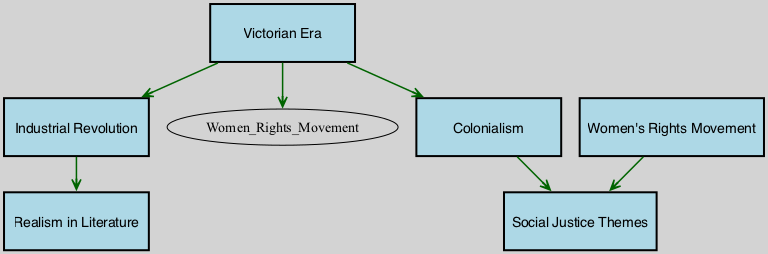What are the total number of nodes in the diagram? There are 6 distinct nodes in the diagram: Victorian Era, Women's Rights Movement, Colonialism, Industrial Revolution, Realism in Literature, and Social Justice Themes.
Answer: 6 Which node is influenced by both Victorian Era and Industrial Revolution? The diagram shows that Realism in Literature is influenced by the Industrial Revolution, and the Victorian Era has direct edges to Women's Rights Movement and Colonialism. Therefore, Realism in Literature is solely influenced by the Industrial Revolution.
Answer: Realism in Literature How many edges lead from the Victorian Era? The Victorian Era has three edges leading to other nodes: Women's Rights Movement, Colonialism, and Industrial Revolution. Counting these edges gives a total of 3.
Answer: 3 What influences the Social Justice Themes node? The Social Justice Themes node is influenced by two edges: one from the Women's Rights Movement and one from Colonialism, indicating that both historical events contribute to this theme.
Answer: Women's Rights Movement, Colonialism What is the relationship between the Industrial Revolution and Realism in Literature? The diagram shows a direct edge from the Industrial Revolution to Realism in Literature, indicating that the Industrial Revolution directly influences this literary movement.
Answer: Direct influence 